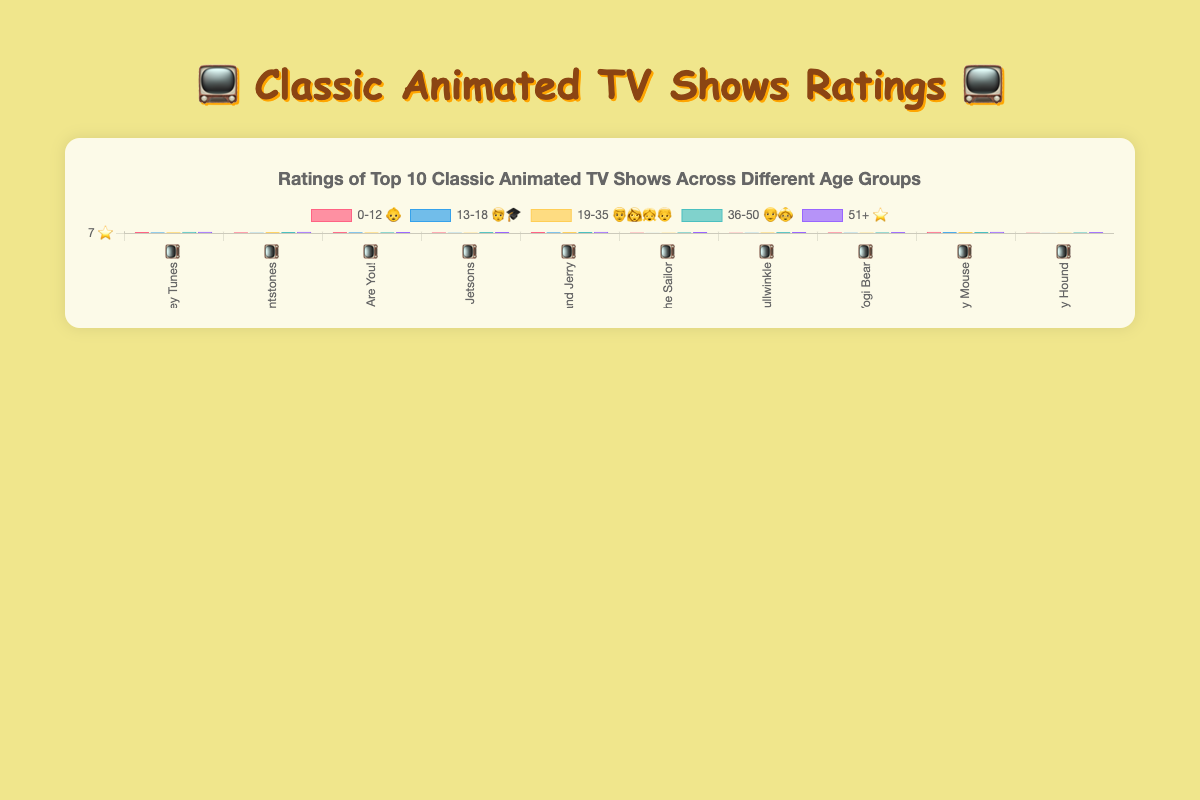What's the title of the chart? 📺 The title is prominently displayed at the top of the chart. It reads "Ratings of Top 10 Classic Animated TV Shows Across Different Age Groups".
Answer: Ratings of Top 10 Classic Animated TV Shows Across Different Age Groups Which classic animated TV show has the highest overall rating for the 51+ age group? 👴👵 By examining the bar heights for the 51+ age group (purple bars), "Looney Tunes" has the highest rating of 9.7.
Answer: Looney Tunes What color represents the 13-18 age group 🧑‍🎓, and how are data points visually represented for this age group? The 13-18 age group is represented by blue bars. Each TV show's rating for this age group is visualized as individual blue bars along the x-axis.
Answer: Blue Which age group has the lowest rating for "Popeye the Sailor"? 👨‍👩‍👧‍👦 The 13-18 age group has the lowest rating for "Popeye the Sailor" at 7.5.
Answer: 13-18 Compare the ratings 📊 of "Tom and Jerry" between the 0-12 and 51+ age groups. Which group rates it higher? The 0-12 age group rating for "Tom and Jerry" is 9.4, while the 51+ age group rating is 9.5. Therefore, the 51+ group rates it slightly higher.
Answer: 51+ What's the average rating ⭐ of "The Jetsons" across all age groups? The ratings for "The Jetsons" are [8.5, 7.9, 8.2, 9.0, 9.4]. Sum these ratings: 8.5 + 7.9 + 8.2 + 9.0 + 9.4 = 43.0. Average is 43.0 / 5 = 8.6.
Answer: 8.6 Which show has the most consistent ratings ⭐ across all age groups, showing the smallest difference between the highest and lowest ratings? Calculate the differences: "Looney Tunes" (9.7-8.5=1.2), "The Flintstones" (9.6-8.0=1.6), "Scooby-Doo, Where Are You!" (9.1-8.5=0.6), "The Jetsons" (9.4-7.9=1.5), "Tom and Jerry" (9.5-8.8=0.7), "Popeye the Sailor" (9.2-7.5=1.7), "Rocky and Bullwinkle" (9.3-7.8=1.5), "Yogi Bear" (9.0-8.0=1.0), "Mickey Mouse" (9.6-8.9=0.7), and "Huckleberry Hound" (8.9-7.6=1.3). Smallest difference is "Scooby-Doo, Where Are You!" with 0.6.
Answer: Scooby-Doo, Where Are You! What is the total number of data points (ratings) shown in the chart? 📊 Each of the 10 TV shows has 5 ratings (one for each age group). Thus, the total number of data points is 10 shows * 5 ratings = 50.
Answer: 50 